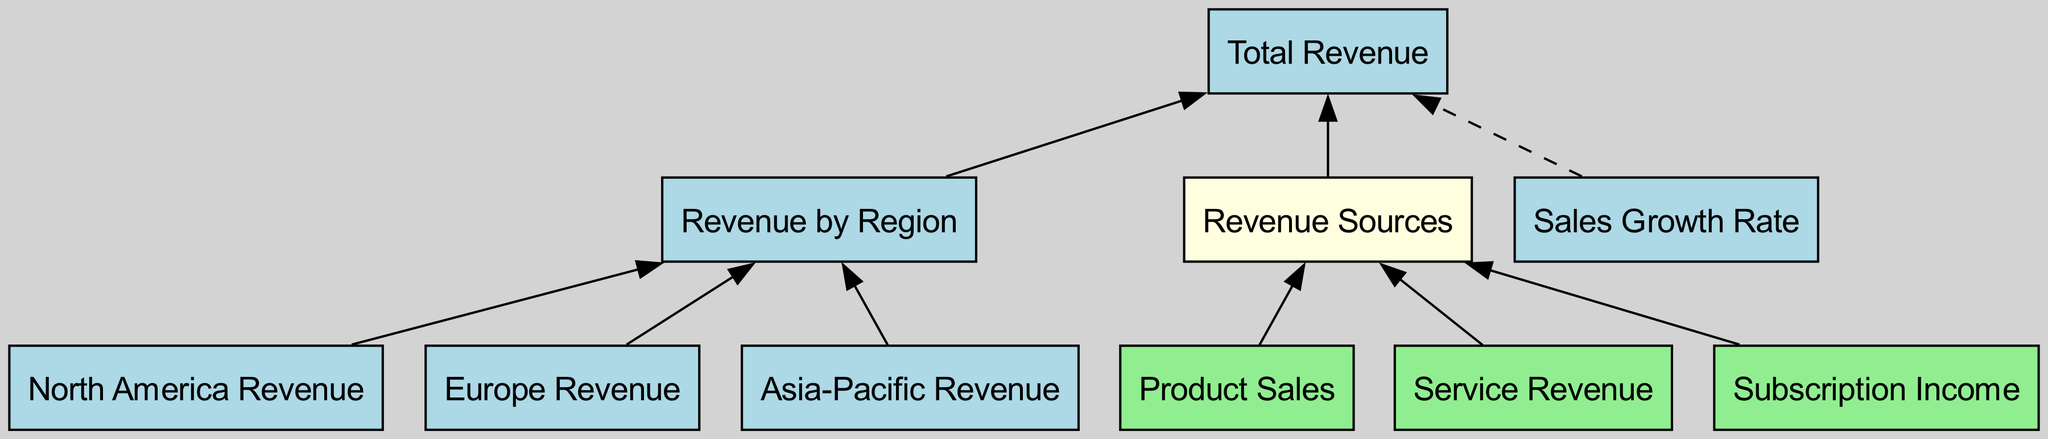What is the total revenue derived from North America? The diagram indicates that there is a node labeled "North America Revenue," which is linked to "Revenue by Region," and further connects to "Total Revenue." However, the exact dollar amount is not shown in the diagram text provided.
Answer: Not available How many regional revenue nodes are present in the diagram? The diagram depicts three specific regional revenue nodes: "North America Revenue," "Europe Revenue," and "Asia-Pacific Revenue." Counting these gives us a total of three regional nodes.
Answer: 3 Which revenue source contributes to the "Revenue Sources" node? The "Revenue Sources" node has direct connections from three distinct nodes: "Product Sales," "Service Revenue," and "Subscription Income." Each of these sources directly contributes to the overall revenue.
Answer: Product Sales, Service Revenue, Subscription Income What is the relationship between "Sales Growth Rate" and "Total Revenue"? According to the diagram, "Sales Growth Rate" is linked to "Total Revenue" with a dashed line, indicating a non-direct correlation. This suggests that while sales growth affects total revenue, it is not a direct source.
Answer: Dashed line How many edges connect the "Revenue by Region" node? The "Revenue by Region" node has three incoming edges: one from "North America Revenue," one from "Europe Revenue," and one from "Asia-Pacific Revenue," plus one outgoing edge leading to "Total Revenue." This totals four edges.
Answer: 4 What types of metrics are represented in the diagram? The diagram features metrics represented in light blue nodes. Specifically, these metrics include "Total Revenue," "Revenue by Region," "Sales Growth Rate," "North America Revenue," "Europe Revenue," and "Asia-Pacific Revenue."
Answer: 5 What color represents the nodes for revenue sources in the diagram? The nodes representing revenue sources, which are "Product Sales," "Service Revenue," and "Subscription Income," are shown in light green color in the diagram.
Answer: Light green How does the "Revenue by Region" node relate to "Total Revenue"? The "Revenue by Region" node has a direct connection leading to the "Total Revenue" node, which indicates that the revenue figures from individual regions combine to form the total revenue.
Answer: Direct connection What does the dashed line signify in the context of this diagram? The dashed line represents the "Sales Growth Rate" as a factor influencing the "Total Revenue," but it suggests it does not directly contribute as a categorical source of revenue.
Answer: Influencing factor 